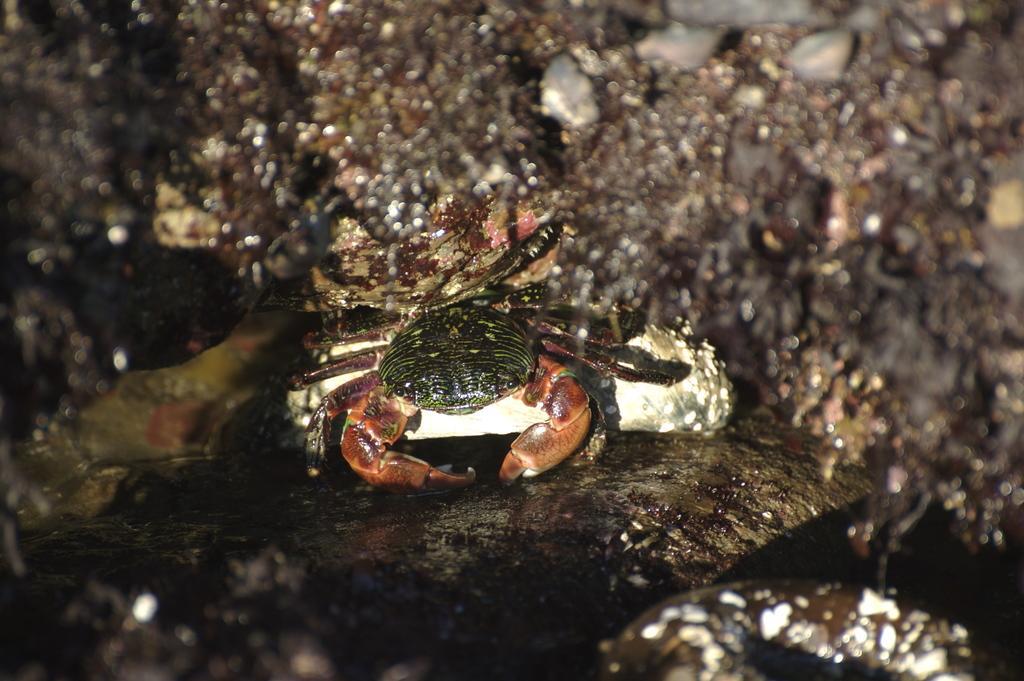Describe this image in one or two sentences. In this picture I can see a crab on the rock, and there is blur background. 